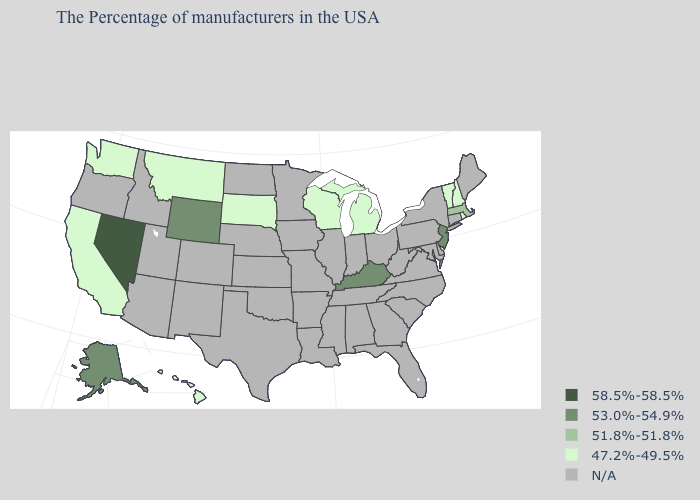What is the value of Massachusetts?
Answer briefly. 51.8%-51.8%. What is the value of Utah?
Write a very short answer. N/A. Name the states that have a value in the range N/A?
Quick response, please. Maine, Connecticut, New York, Delaware, Maryland, Pennsylvania, Virginia, North Carolina, South Carolina, West Virginia, Ohio, Florida, Georgia, Indiana, Alabama, Tennessee, Illinois, Mississippi, Louisiana, Missouri, Arkansas, Minnesota, Iowa, Kansas, Nebraska, Oklahoma, Texas, North Dakota, Colorado, New Mexico, Utah, Arizona, Idaho, Oregon. What is the lowest value in the South?
Short answer required. 53.0%-54.9%. What is the value of Vermont?
Concise answer only. 47.2%-49.5%. What is the highest value in the USA?
Short answer required. 58.5%-58.5%. How many symbols are there in the legend?
Be succinct. 5. Does Kentucky have the lowest value in the USA?
Short answer required. No. What is the value of South Dakota?
Short answer required. 47.2%-49.5%. Which states have the lowest value in the South?
Keep it brief. Kentucky. What is the value of Florida?
Quick response, please. N/A. What is the value of Texas?
Concise answer only. N/A. 